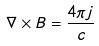Convert formula to latex. <formula><loc_0><loc_0><loc_500><loc_500>\nabla \times B = \frac { 4 \pi j } { c }</formula> 